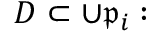<formula> <loc_0><loc_0><loc_500><loc_500>D \subset \cup { \mathfrak { p } } _ { i } \colon</formula> 